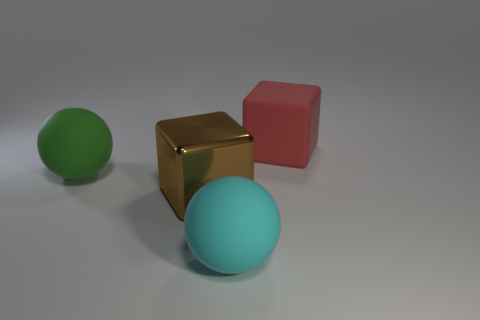Add 2 cyan balls. How many objects exist? 6 Subtract 0 blue spheres. How many objects are left? 4 Subtract all big cyan rubber spheres. Subtract all big green balls. How many objects are left? 2 Add 3 large green objects. How many large green objects are left? 4 Add 3 brown metal objects. How many brown metal objects exist? 4 